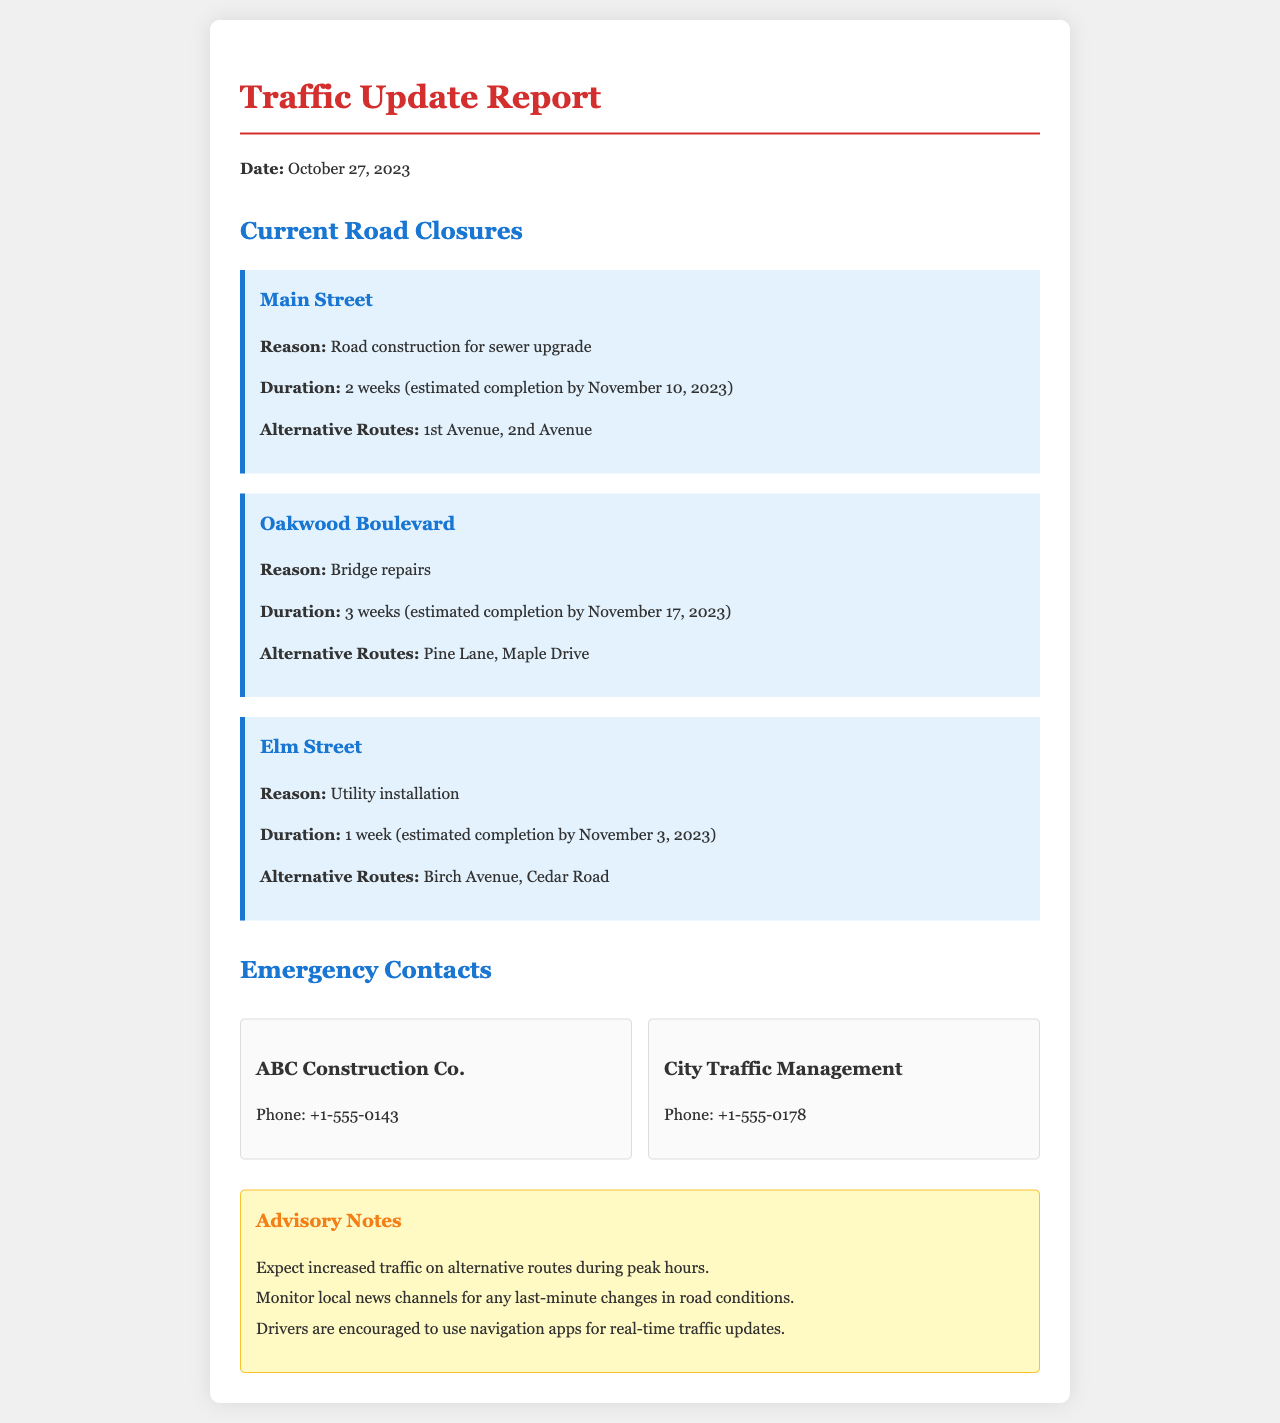What is the reason for the closure of Main Street? The reason for the closure is stated directly in the document under Main Street's closure information.
Answer: Road construction for sewer upgrade When is the estimated completion date for Oakwood Boulevard repairs? The document provides an exact date for when the repairs on Oakwood Boulevard are expected to be completed.
Answer: November 17, 2023 What alternative routes are available for Elm Street? The document lists alternative routes specifically for Elm Street.
Answer: Birch Avenue, Cedar Road How many weeks is Main Street expected to be closed? The duration of the closure for Main Street is explicitly mentioned in the document.
Answer: 2 weeks Which company can be contacted for construction-related inquiries? The document lists a specific contact for construction-related issues.
Answer: ABC Construction Co What should drivers expect on alternative routes during peak hours? The document advises what drivers can expect on alternative routes based on traffic conditions.
Answer: Increased traffic What type of updates are drivers encouraged to use for real-time information? The document specifies what drivers are encouraged to utilize for up-to-date traffic information.
Answer: Navigation apps Which contact has the phone number +1-555-0178? The document includes specific phone contacts, and this number is associated with a traffic management entity.
Answer: City Traffic Management How long is Elm Street closed for utility installation? The document clearly indicates the duration of the closure for utility installation on Elm Street.
Answer: 1 week 